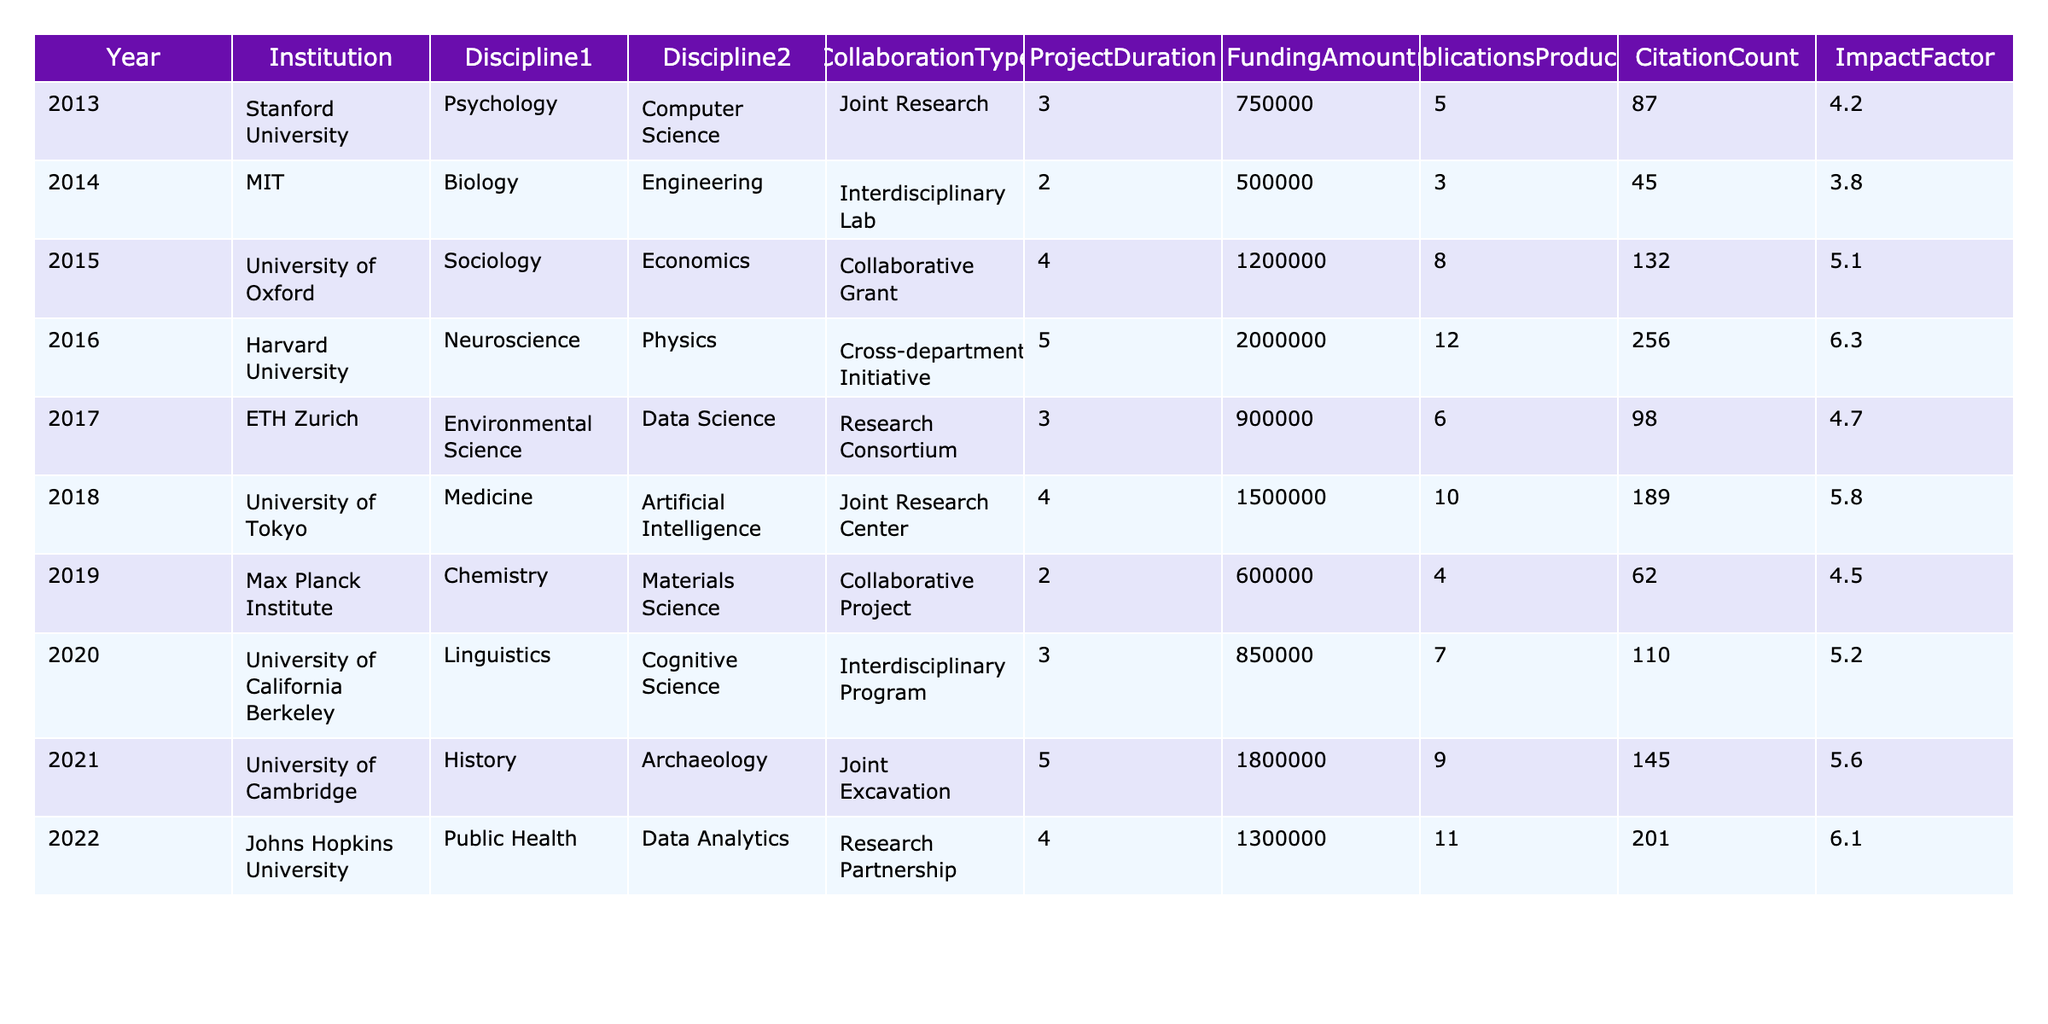What is the total funding amount for interdisciplinary research collaborations over the 10-year period? To find the total funding amount, sum the values in the "FundingAmount" column: 750000 + 500000 + 1200000 + 2000000 + 900000 + 1500000 + 600000 + 850000 + 1800000 + 1300000 = 10,900,000.
Answer: 10900000 How many publications were produced in 2016? Referring to the table, the "PublicationsProduced" value for the year 2016 is 12.
Answer: 12 What year had the highest citation count? By comparing the "CitationCount" values, 256 in 2016 is the highest.
Answer: 2016 What is the average impact factor of the collaborations from 2017 to 2022? The impact factors from 2017 to 2022 are 4.7, 5.8, 4.5, 5.2, 5.6, and 6.1. Summing these values gives 32.9, and dividing by 6 (number of years) gives an average of 32.9 / 6 = 5.48.
Answer: 5.48 Did any interdisciplinary projects from this table exceed a project duration of 5 years? Looking at the "ProjectDuration" column, only the year 2016 has a duration of 5 years; therefore, the answer is yes.
Answer: Yes How many more publications were produced in 2018 compared to 2019? Publications produced in 2018 and 2019 were 10 and 4, respectively. The difference is 10 - 4 = 6.
Answer: 6 What is the total amount of funding for collaborative grants? The "FundingAmount" for collaborative grants in 2015 and 2019 is 1200000 and 600000, respectively. Summing these gives 1200000 + 600000 = 1800000.
Answer: 1800000 Which institution had the second highest amount of funding? By examining the "FundingAmount" column, the highest is 2000000 (Harvard University) and the second highest is 1800000 (University of Cambridge).
Answer: University of Cambridge What are the combined citation counts for all joint research types listed in the table? The citation counts for the joint research projects (2013, 2018) are 87 and 189. Summing these gives 87 + 189 = 276.
Answer: 276 Is there a trend showing an increase in the impact factor over the years in the table? By looking at the "ImpactFactor" column: it increases from 4.2 in 2013 to 6.3 in 2016, then slightly fluctuates but ends at 6.1 in 2022. While there are fluctuations, the overall trend does appear to show an increase over the 10 years.
Answer: Yes 